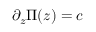Convert formula to latex. <formula><loc_0><loc_0><loc_500><loc_500>\partial _ { z } \Pi ( z ) = c</formula> 